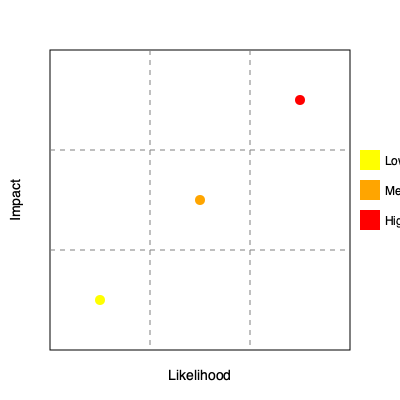As a strategic project manager, you are presented with the risk matrix heat map above for a critical project. Based on the information provided, which risk should be prioritized for immediate mitigation strategies, and why? To answer this question, we need to analyze the risk matrix heat map and understand its components:

1. The x-axis represents the likelihood of a risk occurring, increasing from left to right.
2. The y-axis represents the impact of a risk, increasing from bottom to top.
3. The map is divided into a 3x3 grid, creating 9 cells.
4. Three risk points are plotted on the map, represented by colored circles.

Let's examine each risk point:

1. Yellow point (bottom-left): Low likelihood, low impact
2. Orange point (center): Medium likelihood, medium impact
3. Red point (top-right): High likelihood, high impact

In project risk management, we prioritize risks based on their potential impact and likelihood of occurrence. The risks that have both high impact and high likelihood are considered the most critical and require immediate attention.

Looking at the heat map:
- The red point is in the top-right cell, indicating both high impact and high likelihood.
- The orange point is in the center, representing medium risk.
- The yellow point is in the bottom-left, representing low risk.

As a strategic project manager, you should focus on the risks that pose the greatest threat to the project's success. In this case, the red point represents the highest risk due to its position in the matrix.
Answer: Prioritize the red point (top-right) risk for immediate mitigation due to its high likelihood and high impact. 